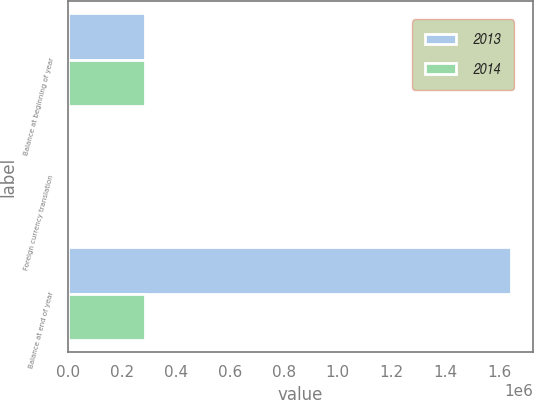Convert chart to OTSL. <chart><loc_0><loc_0><loc_500><loc_500><stacked_bar_chart><ecel><fcel>Balance at beginning of year<fcel>Foreign currency translation<fcel>Balance at end of year<nl><fcel>2013<fcel>284112<fcel>88<fcel>1.64244e+06<nl><fcel>2014<fcel>283833<fcel>1888<fcel>284112<nl></chart> 